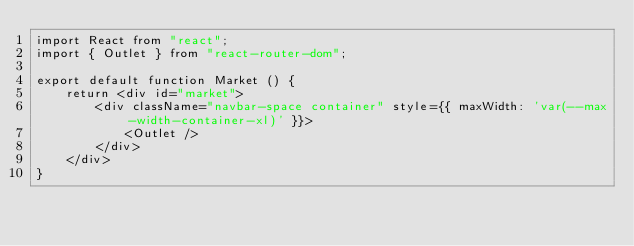<code> <loc_0><loc_0><loc_500><loc_500><_JavaScript_>import React from "react";
import { Outlet } from "react-router-dom";

export default function Market () {
    return <div id="market">
        <div className="navbar-space container" style={{ maxWidth: 'var(--max-width-container-xl)' }}>
            <Outlet />
        </div>
    </div>
}
</code> 